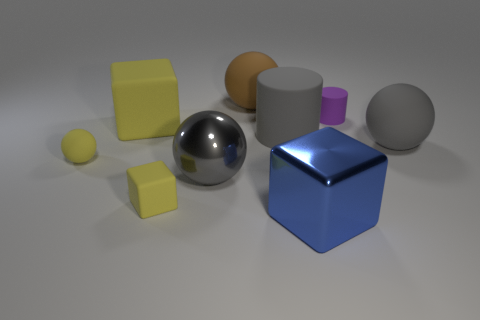Subtract all cyan cylinders. Subtract all red balls. How many cylinders are left? 2 Subtract all balls. How many objects are left? 5 Add 1 brown blocks. How many brown blocks exist? 1 Subtract 0 cyan cylinders. How many objects are left? 9 Subtract all yellow matte cubes. Subtract all big yellow rubber blocks. How many objects are left? 6 Add 6 small yellow cubes. How many small yellow cubes are left? 7 